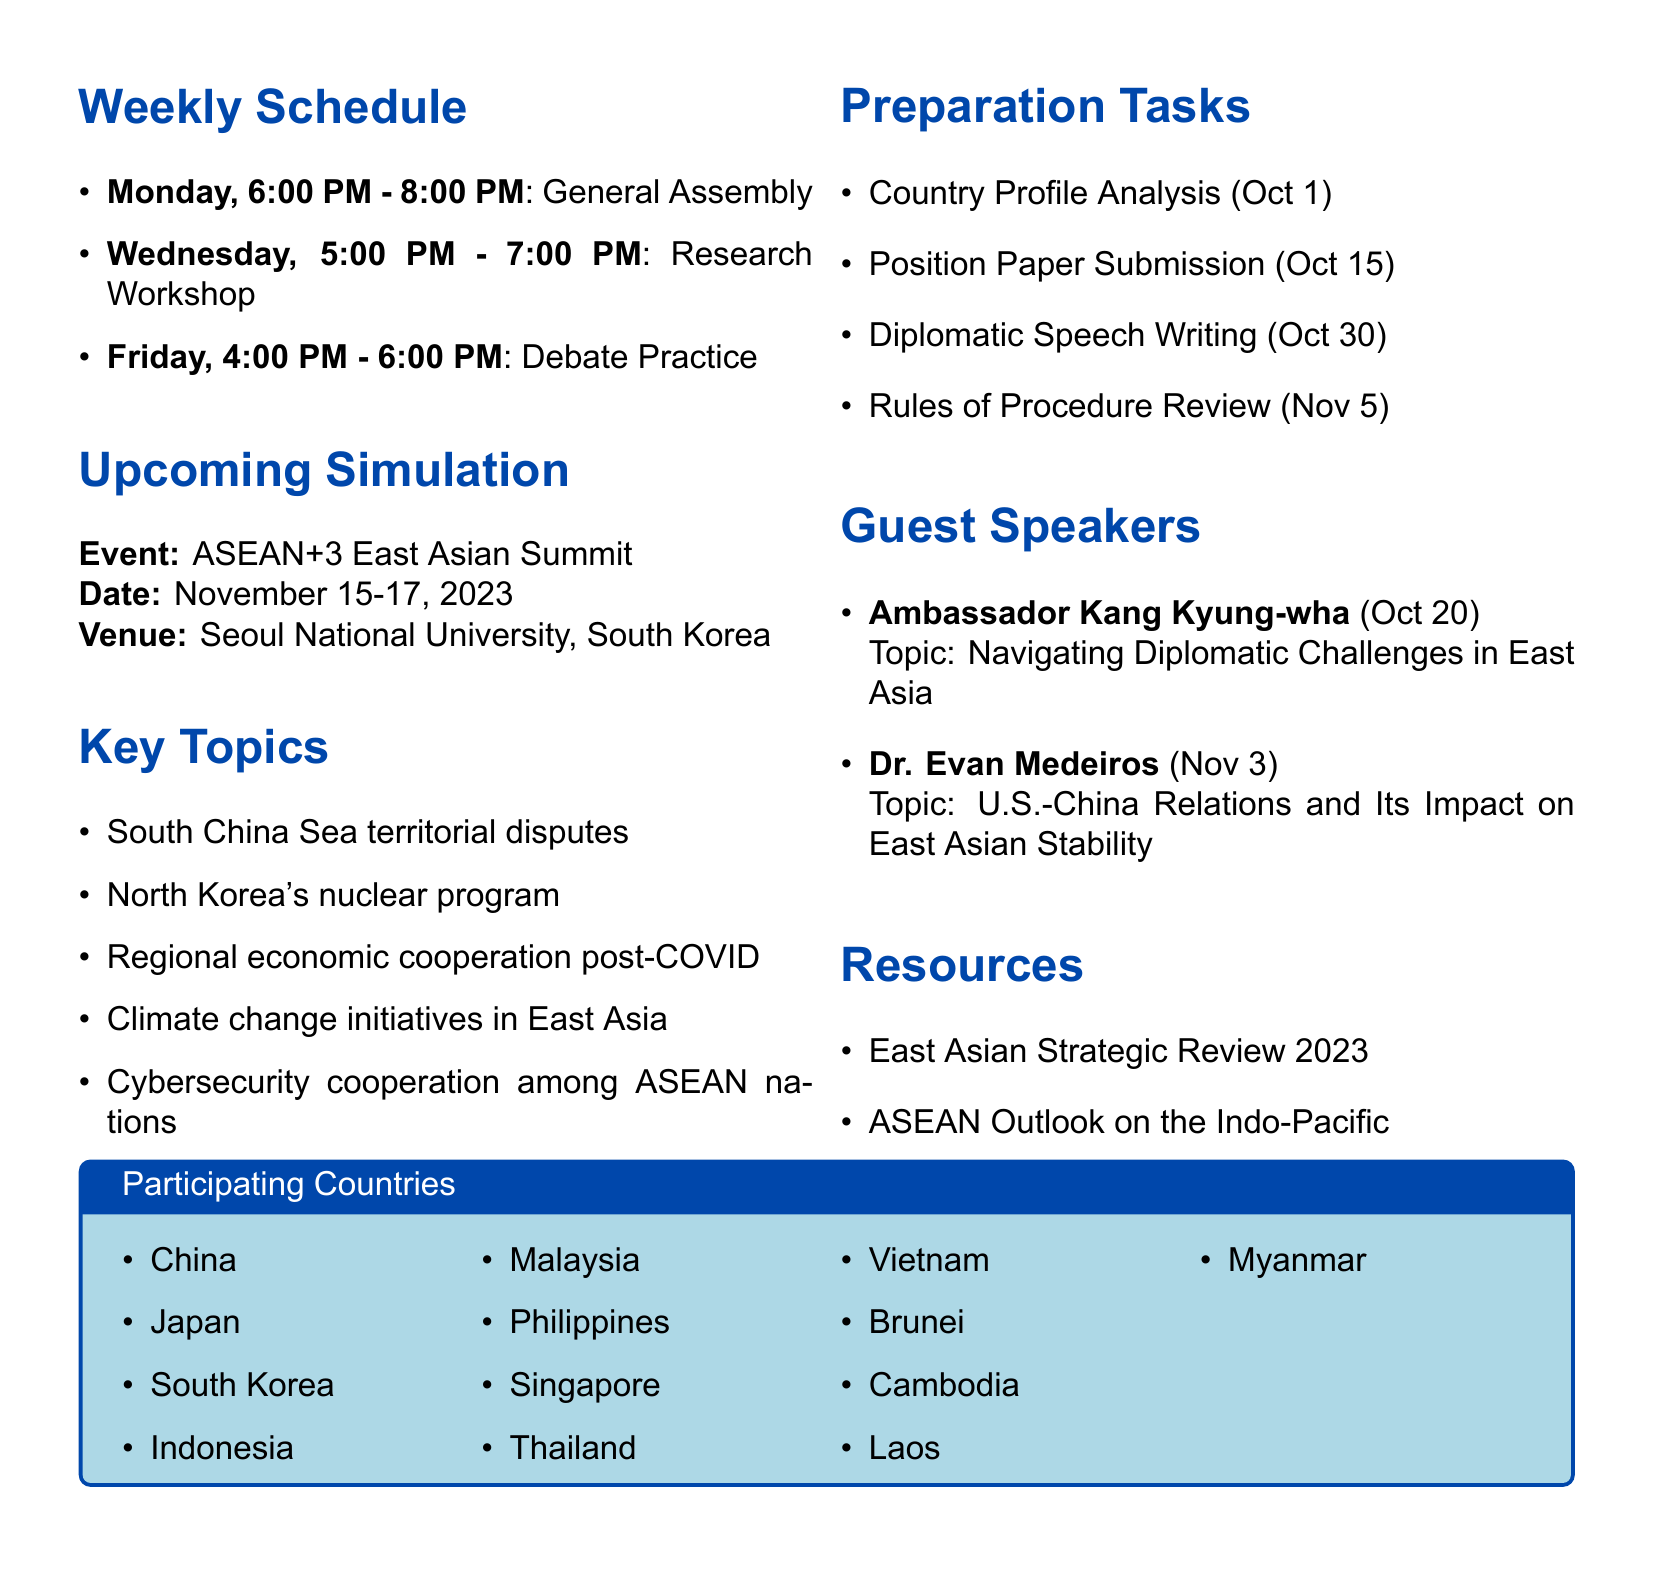What is the name of the club? The club's name is provided at the beginning of the document, which is "East Asian Diplomacy Model UN."
Answer: East Asian Diplomacy Model UN What day and time is the General Assembly scheduled? The meeting schedule includes specific days and times for activities, including the General Assembly on Monday at 6:00 PM - 8:00 PM.
Answer: Monday, 6:00 PM - 8:00 PM When is the ASEAN+3 East Asian Summit taking place? The date for the upcoming simulation is clearly stated in the document as November 15-17, 2023.
Answer: November 15-17, 2023 Who is the guest speaker on October 20, 2023? The document lists guest speakers along with their respective dates, with Ambassador Kang Kyung-wha scheduled for October 20, 2023.
Answer: Ambassador Kang Kyung-wha What is the deadline for the Position Paper Submission? Each preparation task includes a deadline, and the deadline for the Position Paper Submission is October 15, 2023.
Answer: October 15, 2023 How many key topics are listed in the document? The number of key topics outlined in the document can be counted, with five topics clearly listed under the Key Topics section.
Answer: 5 What is the venue for the upcoming simulation? The venue for the simulation is mentioned in the Upcoming Simulation section as Seoul National University, South Korea.
Answer: Seoul National University, South Korea Which country's foreign policy must be analyzed for the Country Profile Analysis? The document implies that each club member is assigned a country for analysis as part of the preparation tasks, but does not specify which country, prompting the need for clarity.
Answer: Assigned country What are the participating countries listed in the document? The document lists a total of twelve participating countries, each of which can be found in the Participating Countries section.
Answer: China, Japan, South Korea, Indonesia, Malaysia, Philippines, Singapore, Thailand, Vietnam, Brunei, Cambodia, Laos, Myanmar 